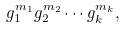Convert formula to latex. <formula><loc_0><loc_0><loc_500><loc_500>g _ { 1 } ^ { m _ { 1 } } g _ { 2 } ^ { m _ { 2 } } \cdots g _ { k } ^ { m _ { k } } ,</formula> 